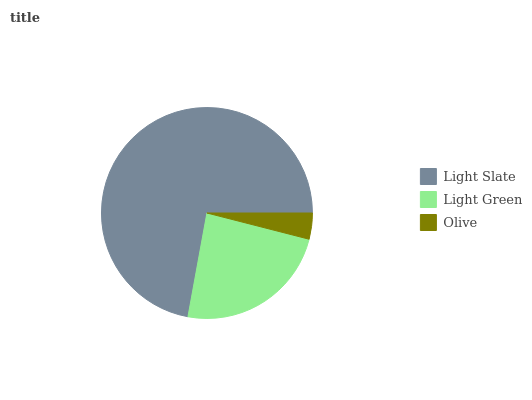Is Olive the minimum?
Answer yes or no. Yes. Is Light Slate the maximum?
Answer yes or no. Yes. Is Light Green the minimum?
Answer yes or no. No. Is Light Green the maximum?
Answer yes or no. No. Is Light Slate greater than Light Green?
Answer yes or no. Yes. Is Light Green less than Light Slate?
Answer yes or no. Yes. Is Light Green greater than Light Slate?
Answer yes or no. No. Is Light Slate less than Light Green?
Answer yes or no. No. Is Light Green the high median?
Answer yes or no. Yes. Is Light Green the low median?
Answer yes or no. Yes. Is Olive the high median?
Answer yes or no. No. Is Light Slate the low median?
Answer yes or no. No. 